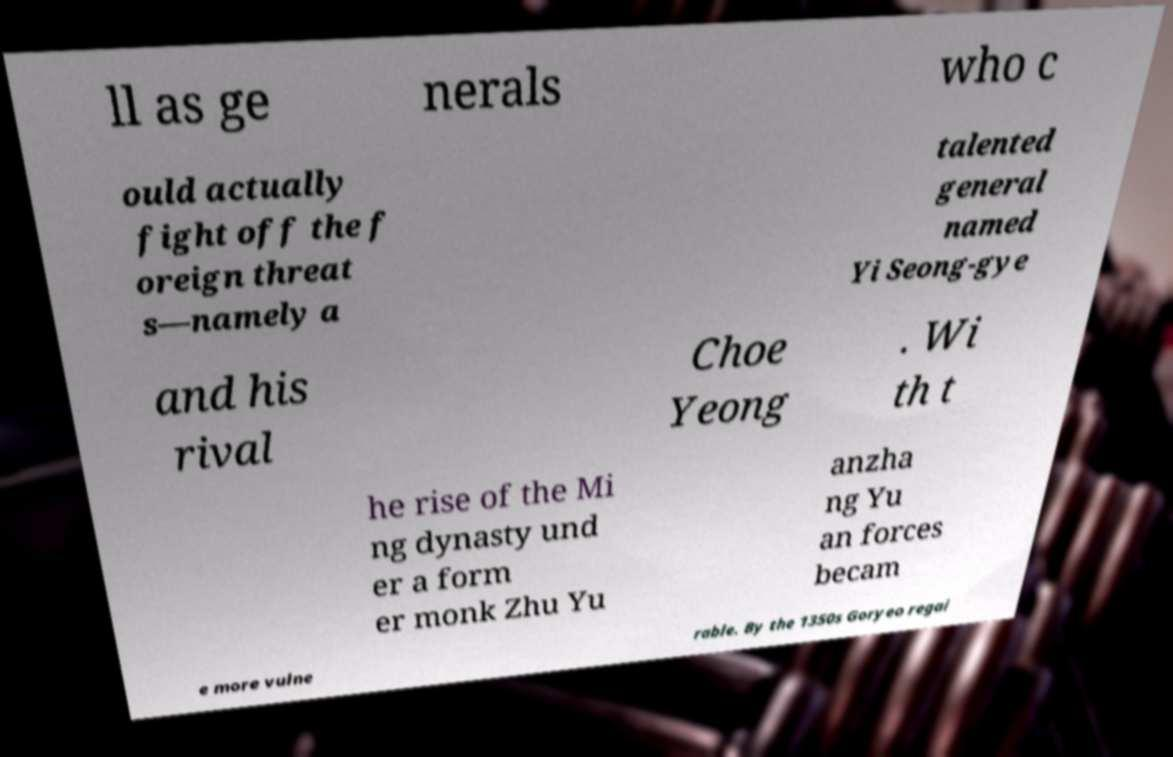Please identify and transcribe the text found in this image. ll as ge nerals who c ould actually fight off the f oreign threat s—namely a talented general named Yi Seong-gye and his rival Choe Yeong . Wi th t he rise of the Mi ng dynasty und er a form er monk Zhu Yu anzha ng Yu an forces becam e more vulne rable. By the 1350s Goryeo regai 